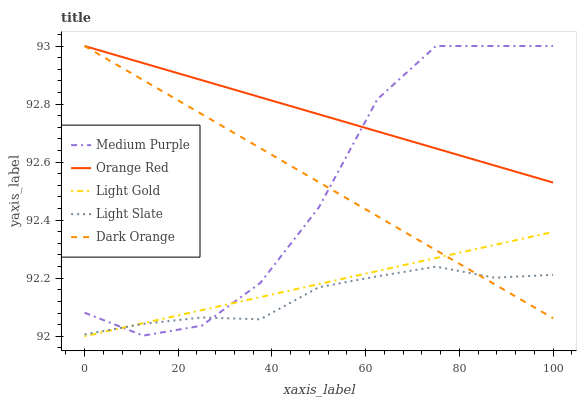Does Light Slate have the minimum area under the curve?
Answer yes or no. Yes. Does Orange Red have the maximum area under the curve?
Answer yes or no. Yes. Does Light Gold have the minimum area under the curve?
Answer yes or no. No. Does Light Gold have the maximum area under the curve?
Answer yes or no. No. Is Light Gold the smoothest?
Answer yes or no. Yes. Is Medium Purple the roughest?
Answer yes or no. Yes. Is Light Slate the smoothest?
Answer yes or no. No. Is Light Slate the roughest?
Answer yes or no. No. Does Light Gold have the lowest value?
Answer yes or no. Yes. Does Light Slate have the lowest value?
Answer yes or no. No. Does Dark Orange have the highest value?
Answer yes or no. Yes. Does Light Gold have the highest value?
Answer yes or no. No. Is Light Slate less than Orange Red?
Answer yes or no. Yes. Is Orange Red greater than Light Gold?
Answer yes or no. Yes. Does Light Slate intersect Light Gold?
Answer yes or no. Yes. Is Light Slate less than Light Gold?
Answer yes or no. No. Is Light Slate greater than Light Gold?
Answer yes or no. No. Does Light Slate intersect Orange Red?
Answer yes or no. No. 